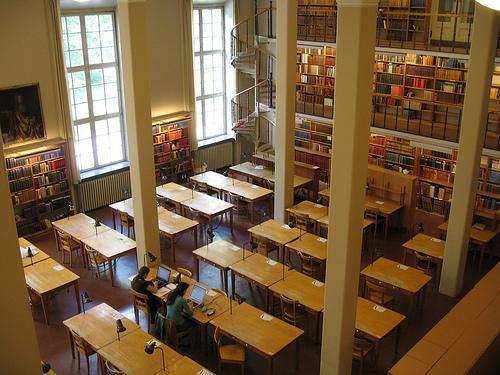How many people are sitting in the library?
Give a very brief answer. 2. 